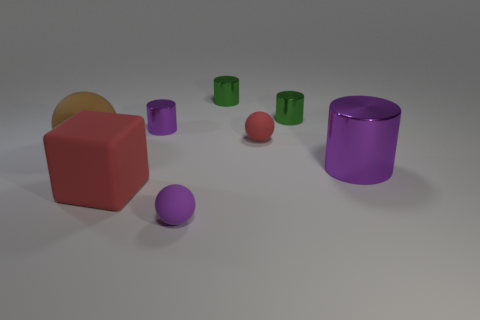There is a large block; does it have the same color as the tiny matte thing behind the big purple cylinder? yes 